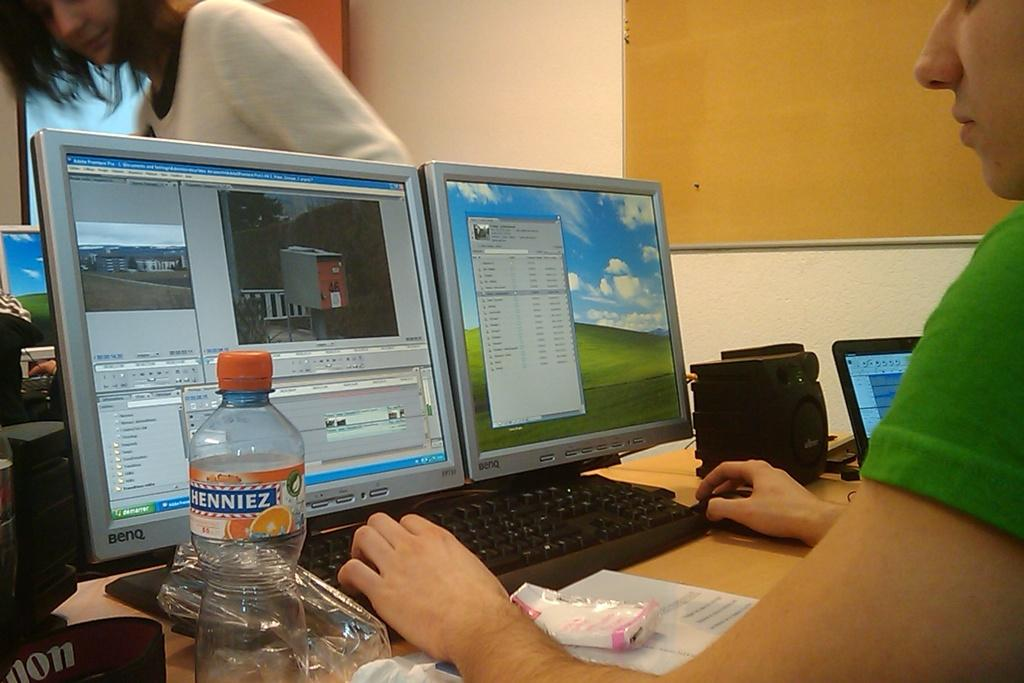<image>
Write a terse but informative summary of the picture. A person works at two computer monitors wiht a bottle of Henniez water next to them. 